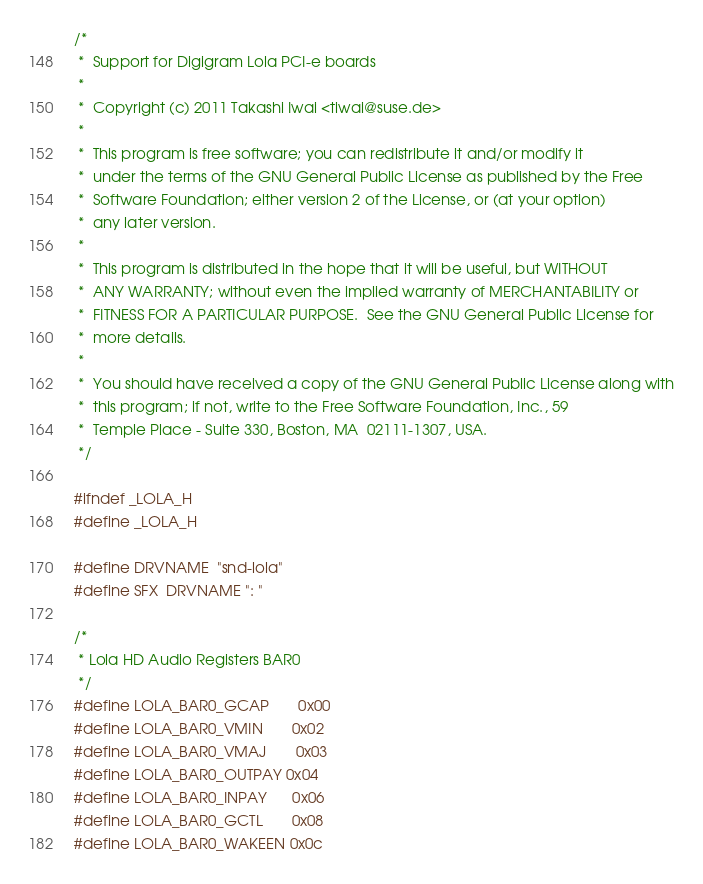Convert code to text. <code><loc_0><loc_0><loc_500><loc_500><_C_>/*
 *  Support for Digigram Lola PCI-e boards
 *
 *  Copyright (c) 2011 Takashi Iwai <tiwai@suse.de>
 *
 *  This program is free software; you can redistribute it and/or modify it
 *  under the terms of the GNU General Public License as published by the Free
 *  Software Foundation; either version 2 of the License, or (at your option)
 *  any later version.
 *
 *  This program is distributed in the hope that it will be useful, but WITHOUT
 *  ANY WARRANTY; without even the implied warranty of MERCHANTABILITY or
 *  FITNESS FOR A PARTICULAR PURPOSE.  See the GNU General Public License for
 *  more details.
 *
 *  You should have received a copy of the GNU General Public License along with
 *  this program; if not, write to the Free Software Foundation, Inc., 59
 *  Temple Place - Suite 330, Boston, MA  02111-1307, USA.
 */

#ifndef _LOLA_H
#define _LOLA_H

#define DRVNAME	"snd-lola"
#define SFX	DRVNAME ": "

/*
 * Lola HD Audio Registers BAR0
 */
#define LOLA_BAR0_GCAP		0x00
#define LOLA_BAR0_VMIN		0x02
#define LOLA_BAR0_VMAJ		0x03
#define LOLA_BAR0_OUTPAY	0x04
#define LOLA_BAR0_INPAY		0x06
#define LOLA_BAR0_GCTL		0x08
#define LOLA_BAR0_WAKEEN	0x0c</code> 